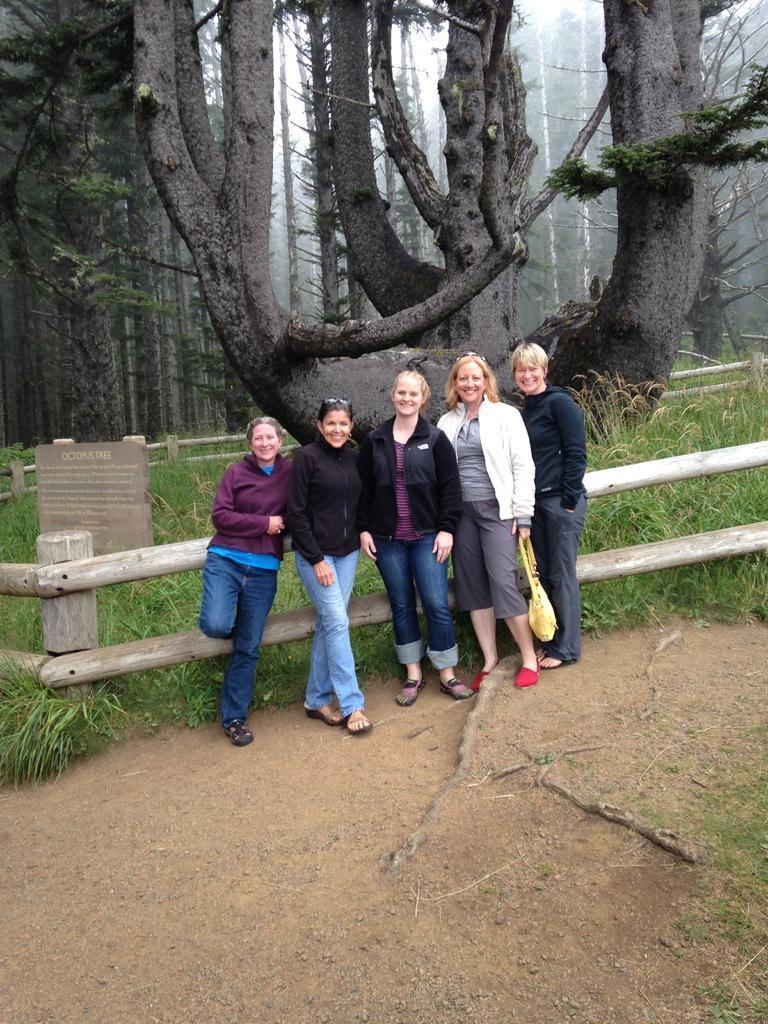How would you summarize this image in a sentence or two? In the center of the image, we can see people standing and smiling and in the background, there is a fence, a board and some trees are present. 